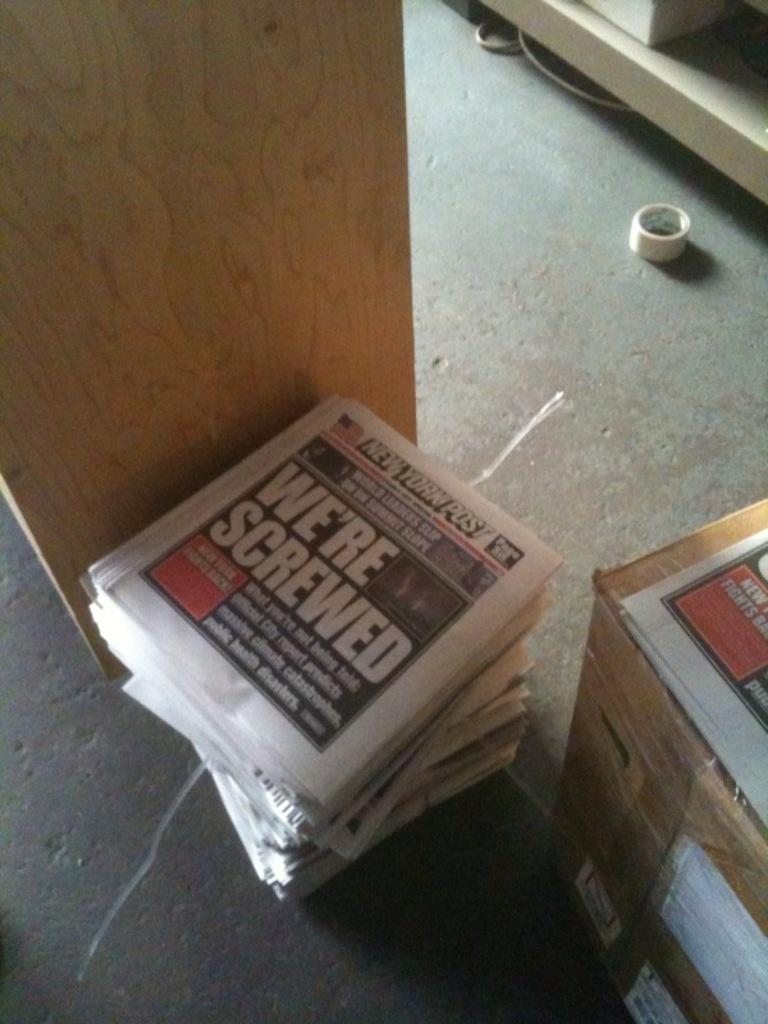<image>
Write a terse but informative summary of the picture. a stack of newspapers that have the headline, we're screwed 